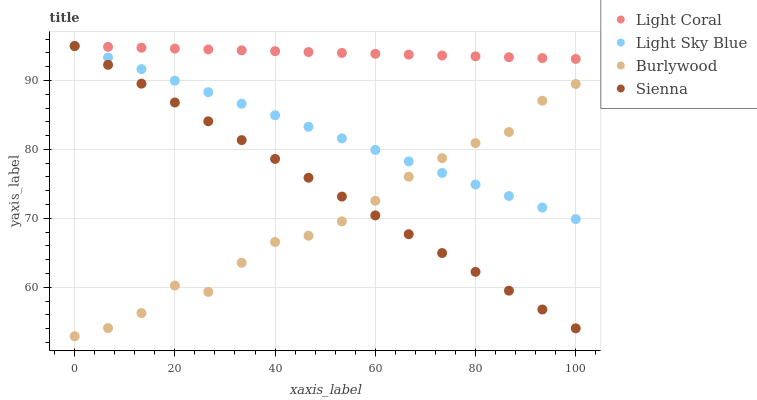Does Burlywood have the minimum area under the curve?
Answer yes or no. Yes. Does Light Coral have the maximum area under the curve?
Answer yes or no. Yes. Does Light Sky Blue have the minimum area under the curve?
Answer yes or no. No. Does Light Sky Blue have the maximum area under the curve?
Answer yes or no. No. Is Sienna the smoothest?
Answer yes or no. Yes. Is Burlywood the roughest?
Answer yes or no. Yes. Is Light Sky Blue the smoothest?
Answer yes or no. No. Is Light Sky Blue the roughest?
Answer yes or no. No. Does Burlywood have the lowest value?
Answer yes or no. Yes. Does Light Sky Blue have the lowest value?
Answer yes or no. No. Does Sienna have the highest value?
Answer yes or no. Yes. Does Burlywood have the highest value?
Answer yes or no. No. Is Burlywood less than Light Coral?
Answer yes or no. Yes. Is Light Coral greater than Burlywood?
Answer yes or no. Yes. Does Light Sky Blue intersect Burlywood?
Answer yes or no. Yes. Is Light Sky Blue less than Burlywood?
Answer yes or no. No. Is Light Sky Blue greater than Burlywood?
Answer yes or no. No. Does Burlywood intersect Light Coral?
Answer yes or no. No. 